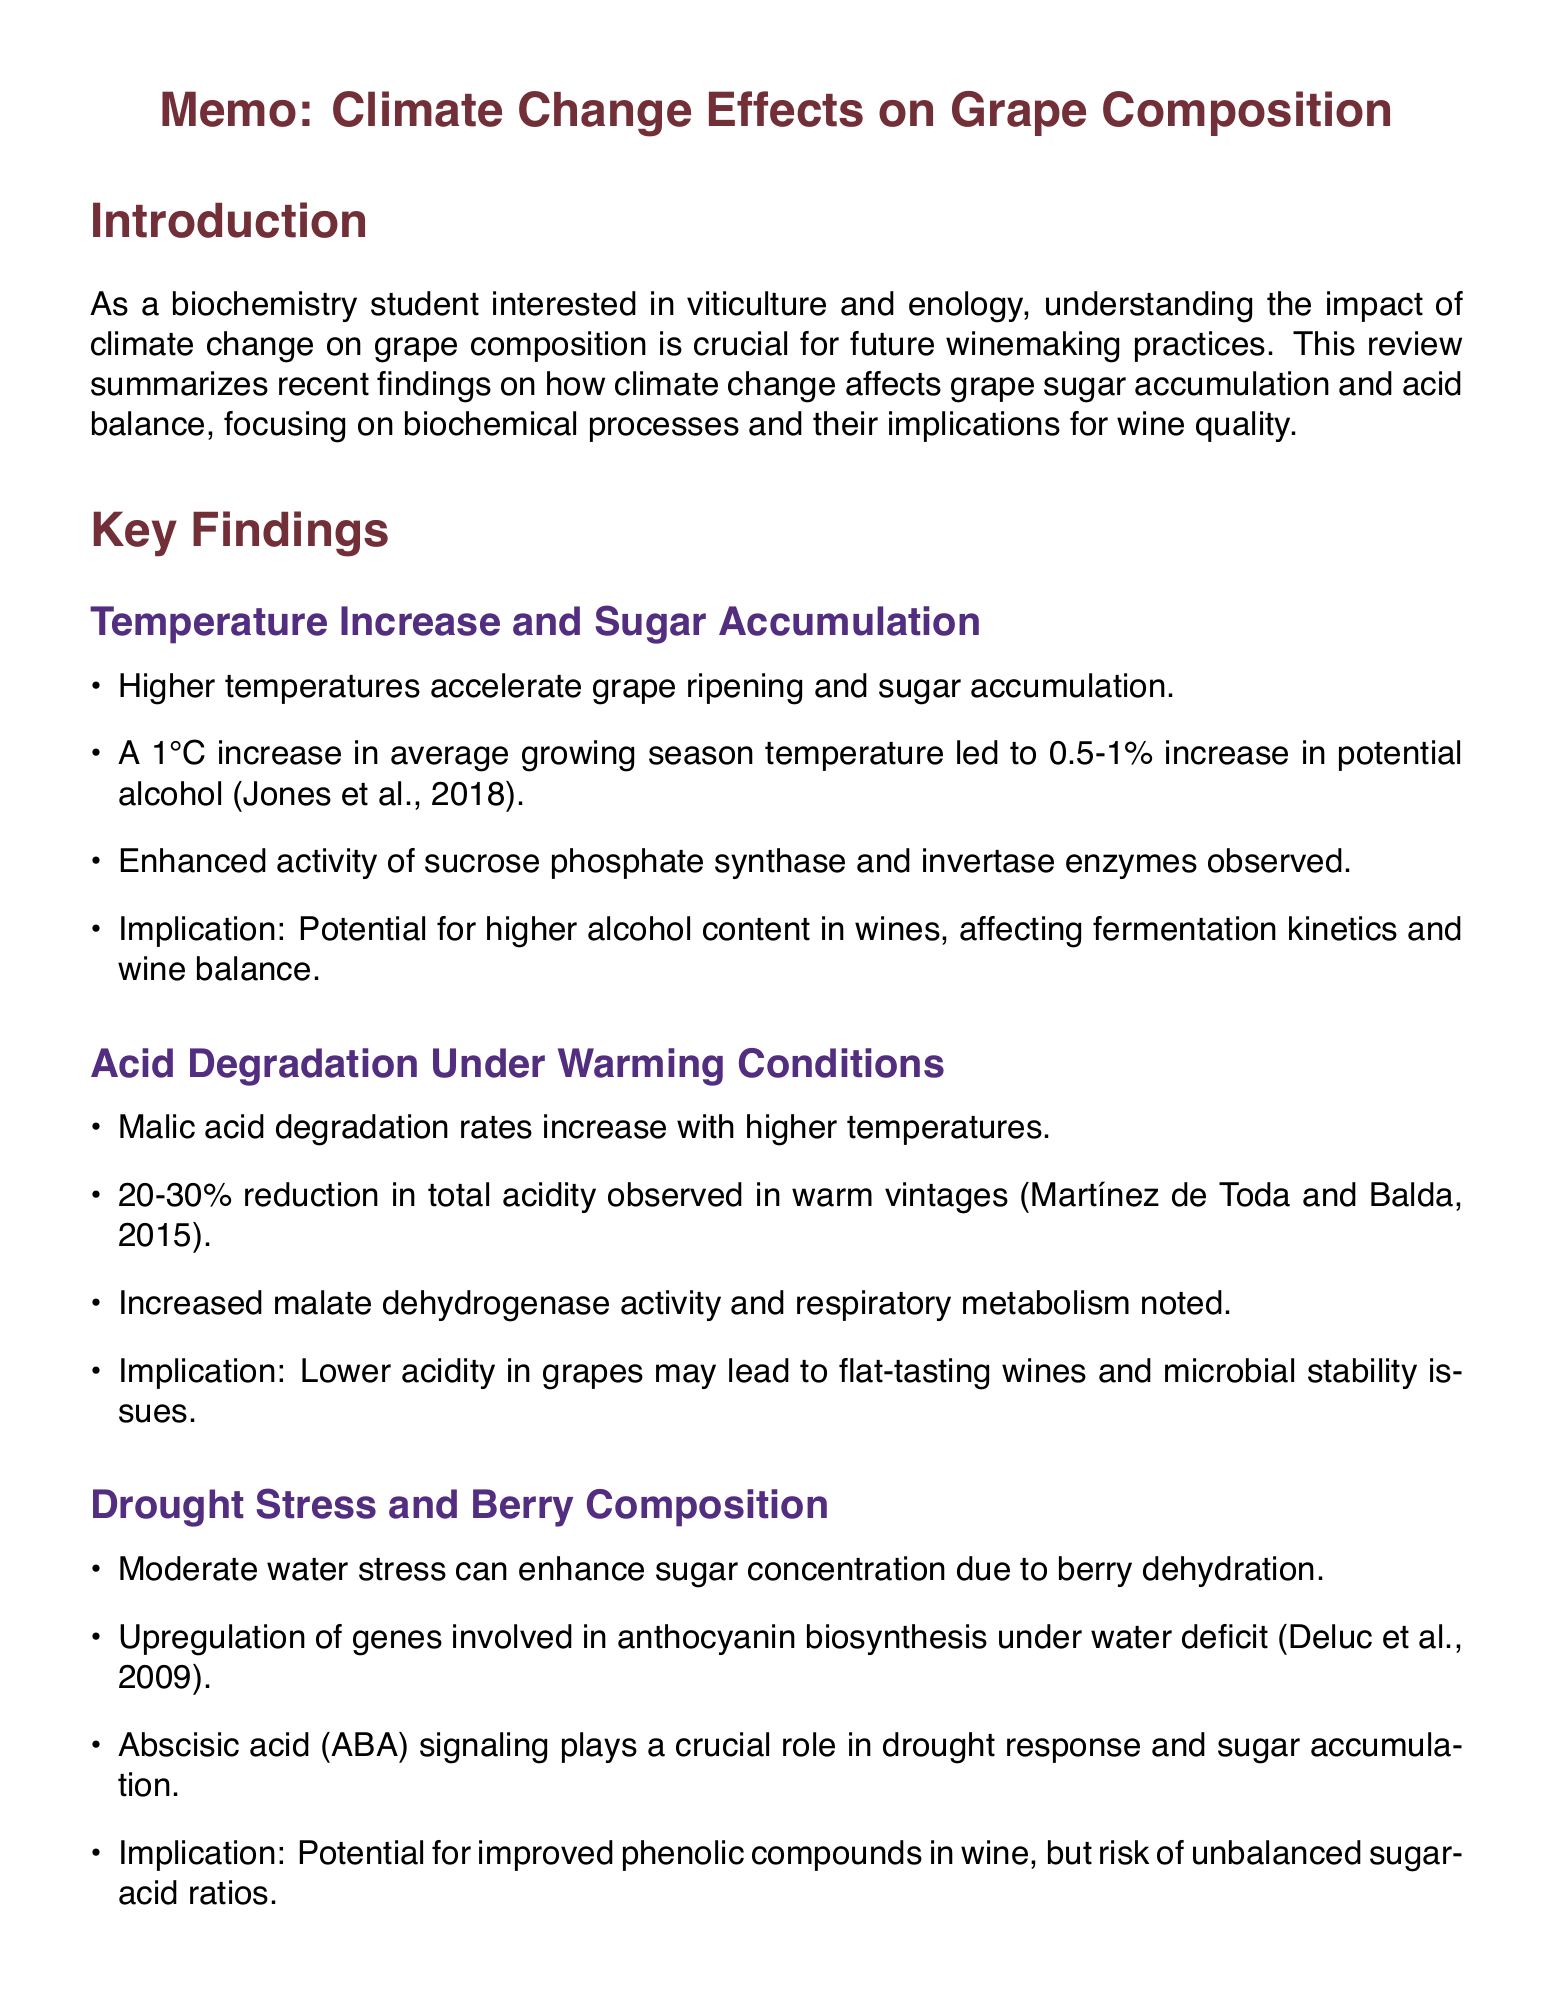What is the main objective of the literature review? The objective is to summarize recent findings on how climate change affects grape sugar accumulation and acid balance.
Answer: Summarize recent findings on how climate change affects grape sugar accumulation and acid balance Which biochemical pathway is enhanced due to temperature increase? The document mentions enhanced activity of sucrose phosphate synthase and invertase enzymes.
Answer: Sucrose phosphate synthase and invertase enzymes What percentage reduction in total acidity was observed in warm vintages? Research by Martínez de Toda and Balda noted a 20-30% reduction in total acidity.
Answer: 20-30% What role does Abscisic acid (ABA) play in drought response? Abscisic acid (ABA) signaling plays a crucial role in drought response and sugar accumulation.
Answer: Drought response and sugar accumulation What is a potential implication of lower acidity in grapes? The implication is that lower acidity may lead to flat-tasting wines and microbial stability issues.
Answer: Flat-tasting wines and microbial stability issues Which two genes activity is mentioned in relation to elevated CO2 conditions? The document references enhanced activity of Rubisco and phosphoenolpyruvate carboxylase.
Answer: Rubisco and phosphoenolpyruvate carboxylase What adaptation strategy involves managing sunlight exposure? Canopy management techniques are designed to mitigate excessive sun exposure.
Answer: Canopy management techniques What is the conclusion regarding climate change and winemaking? The conclusion emphasizes that climate change significantly impacts grape sugar accumulation and acid balance.
Answer: Impact on grape sugar accumulation and acid balance 